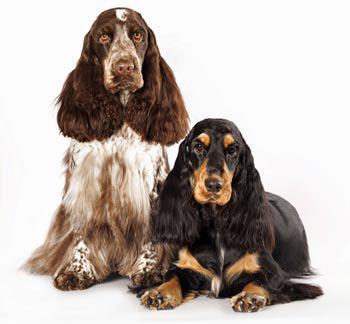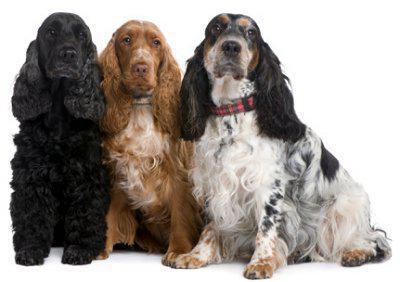The first image is the image on the left, the second image is the image on the right. Evaluate the accuracy of this statement regarding the images: "Some of the dogs are shown outside.". Is it true? Answer yes or no. No. The first image is the image on the left, the second image is the image on the right. Assess this claim about the two images: "Five spaniels are shown, in total.". Correct or not? Answer yes or no. Yes. The first image is the image on the left, the second image is the image on the right. For the images displayed, is the sentence "There are multiple dogs in the right image and they are all the same color." factually correct? Answer yes or no. No. The first image is the image on the left, the second image is the image on the right. Given the left and right images, does the statement "There are three dogs in one of the images." hold true? Answer yes or no. Yes. The first image is the image on the left, the second image is the image on the right. Considering the images on both sides, is "The right image contains exactly three dogs." valid? Answer yes or no. Yes. 